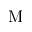Convert formula to latex. <formula><loc_0><loc_0><loc_500><loc_500>M</formula> 